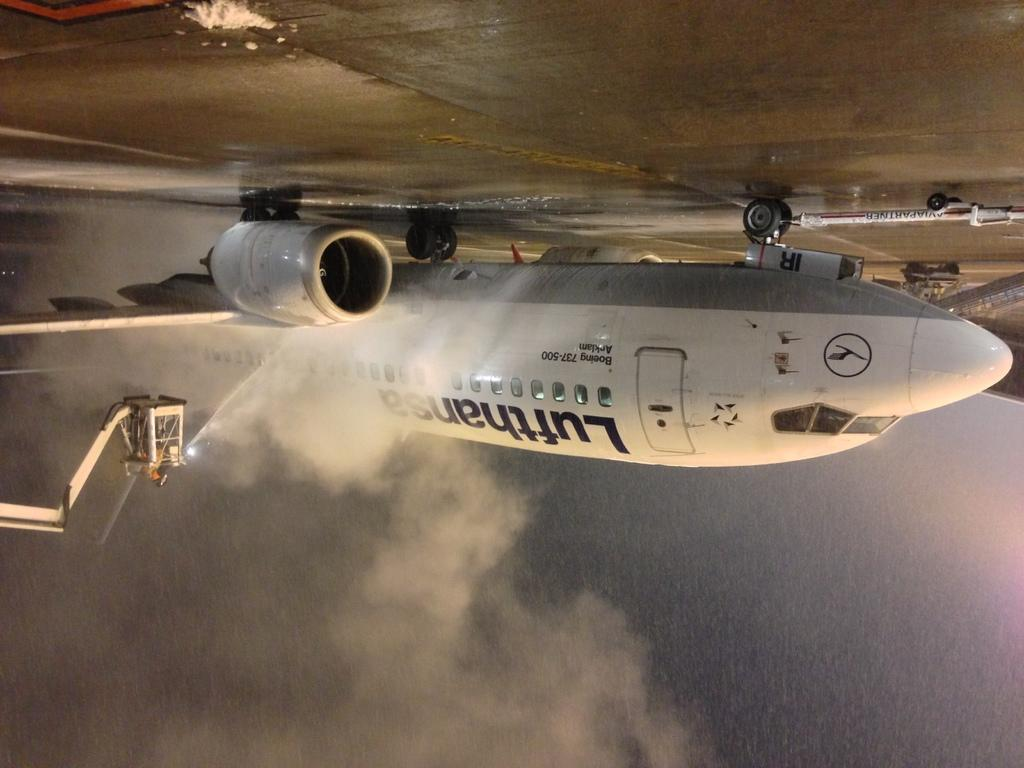<image>
Render a clear and concise summary of the photo. An upside down image of a Lufthansa airplane being sprayed with water. 